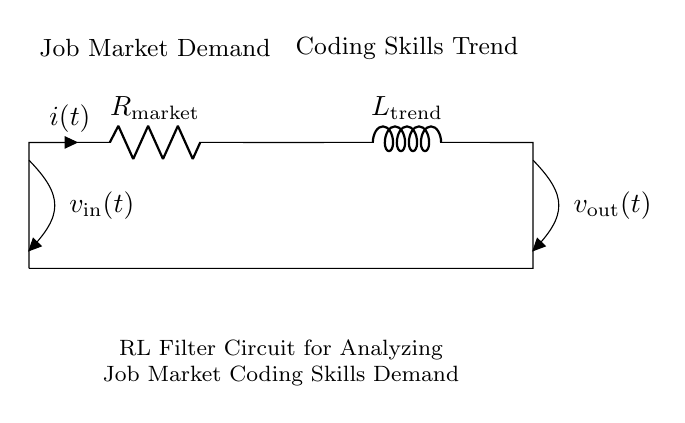What is the resistance value in the circuit? The circuit shows a resistor labeled as R_market, but does not specify its numerical value. In general, the resistance can vary depending on the context.
Answer: R_market What is the name of the component connected in parallel with R_market? The component in series with R_market is an inductor labeled as L_trend. Since it's connected along the same path, it is not parallel, but it is the next component in line after the resistor.
Answer: L_trend What does the input voltage represent in the context of this circuit? The input voltage labeled as v_in(t) represents the external factors affecting the job market demand, influencing how coding skills are required over time.
Answer: v_in(t) What are the two main trends represented in this circuit layout? The circuit incorporates two primary aspects: job market demand and coding skills trend, showcasing the relationship between the two as currents and voltages in the circuit.
Answer: Job Market Demand and Coding Skills Trend How does the inductor affect the filtering of job market trends? The inductor in the circuit, due to its property to oppose changes in current, helps smooth out fluctuations in job market demand over time, allowing for the analysis of long-term trends in coding skill demands.
Answer: Smooths fluctuations What does v_out(t) indicate in the circuit? The output voltage labeled as v_out(t) reflects the processed information of the job market demand filtered through the RL circuit, indicating the level of demand for coding skills at a given time.
Answer: v_out(t) What type of filter is represented by this RL circuit? This RL filter circuit is a type of low-pass filter, which allows low-frequency signals (long-term trends) to pass while attenuating high-frequency signals (short-term fluctuations).
Answer: Low-pass filter 